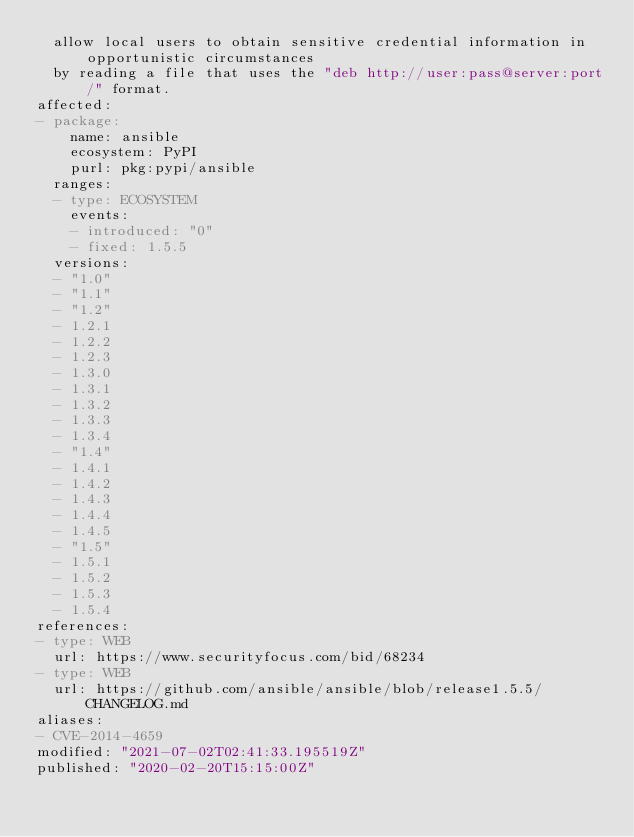<code> <loc_0><loc_0><loc_500><loc_500><_YAML_>  allow local users to obtain sensitive credential information in opportunistic circumstances
  by reading a file that uses the "deb http://user:pass@server:port/" format.
affected:
- package:
    name: ansible
    ecosystem: PyPI
    purl: pkg:pypi/ansible
  ranges:
  - type: ECOSYSTEM
    events:
    - introduced: "0"
    - fixed: 1.5.5
  versions:
  - "1.0"
  - "1.1"
  - "1.2"
  - 1.2.1
  - 1.2.2
  - 1.2.3
  - 1.3.0
  - 1.3.1
  - 1.3.2
  - 1.3.3
  - 1.3.4
  - "1.4"
  - 1.4.1
  - 1.4.2
  - 1.4.3
  - 1.4.4
  - 1.4.5
  - "1.5"
  - 1.5.1
  - 1.5.2
  - 1.5.3
  - 1.5.4
references:
- type: WEB
  url: https://www.securityfocus.com/bid/68234
- type: WEB
  url: https://github.com/ansible/ansible/blob/release1.5.5/CHANGELOG.md
aliases:
- CVE-2014-4659
modified: "2021-07-02T02:41:33.195519Z"
published: "2020-02-20T15:15:00Z"
</code> 